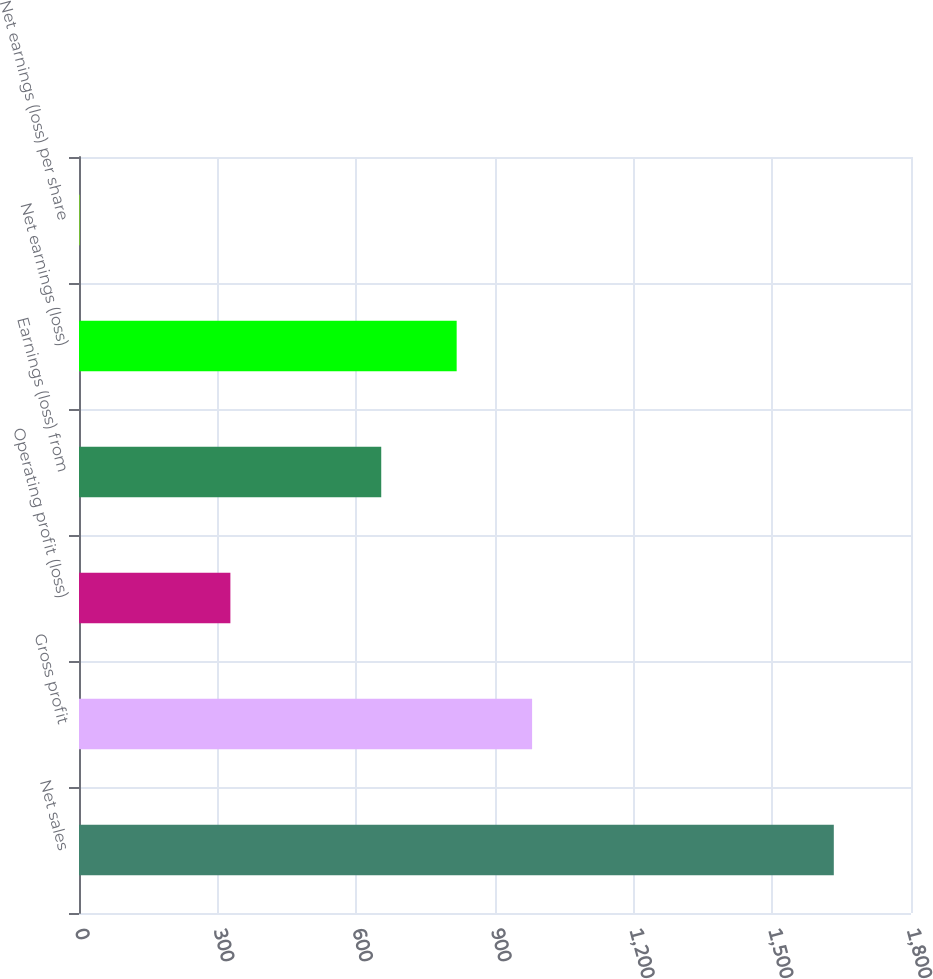Convert chart to OTSL. <chart><loc_0><loc_0><loc_500><loc_500><bar_chart><fcel>Net sales<fcel>Gross profit<fcel>Operating profit (loss)<fcel>Earnings (loss) from<fcel>Net earnings (loss)<fcel>Net earnings (loss) per share<nl><fcel>1633<fcel>980.26<fcel>327.52<fcel>653.88<fcel>817.07<fcel>1.15<nl></chart> 